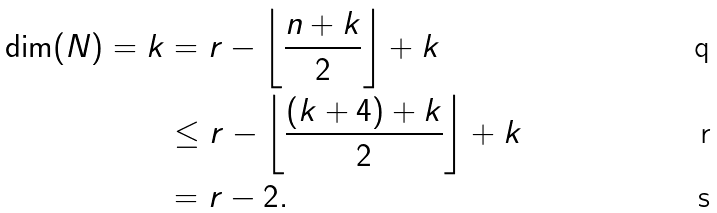<formula> <loc_0><loc_0><loc_500><loc_500>\dim ( N ) = k & = r - \left \lfloor \frac { n + k } { 2 } \right \rfloor + k \\ & \leq r - \left \lfloor \frac { ( k + 4 ) + k } { 2 } \right \rfloor + k \\ & = r - 2 .</formula> 